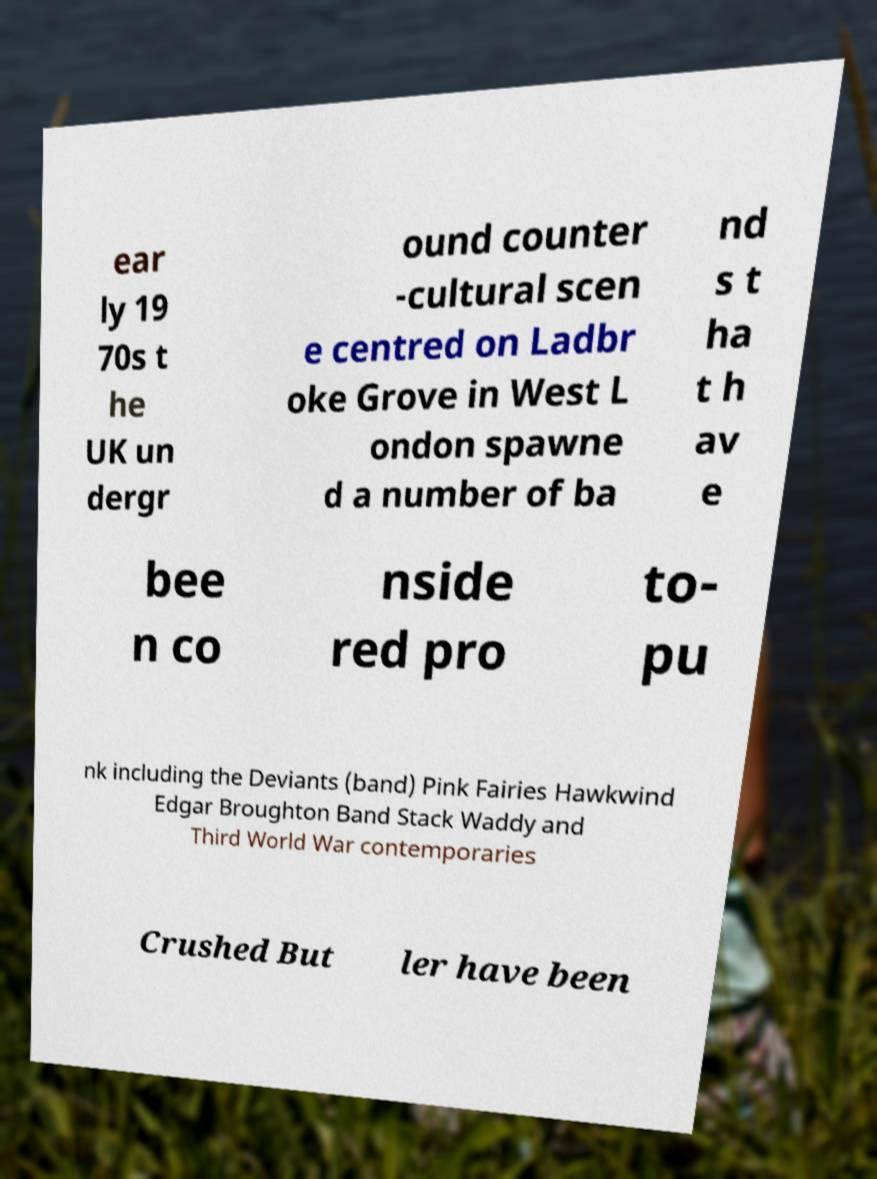I need the written content from this picture converted into text. Can you do that? ear ly 19 70s t he UK un dergr ound counter -cultural scen e centred on Ladbr oke Grove in West L ondon spawne d a number of ba nd s t ha t h av e bee n co nside red pro to- pu nk including the Deviants (band) Pink Fairies Hawkwind Edgar Broughton Band Stack Waddy and Third World War contemporaries Crushed But ler have been 